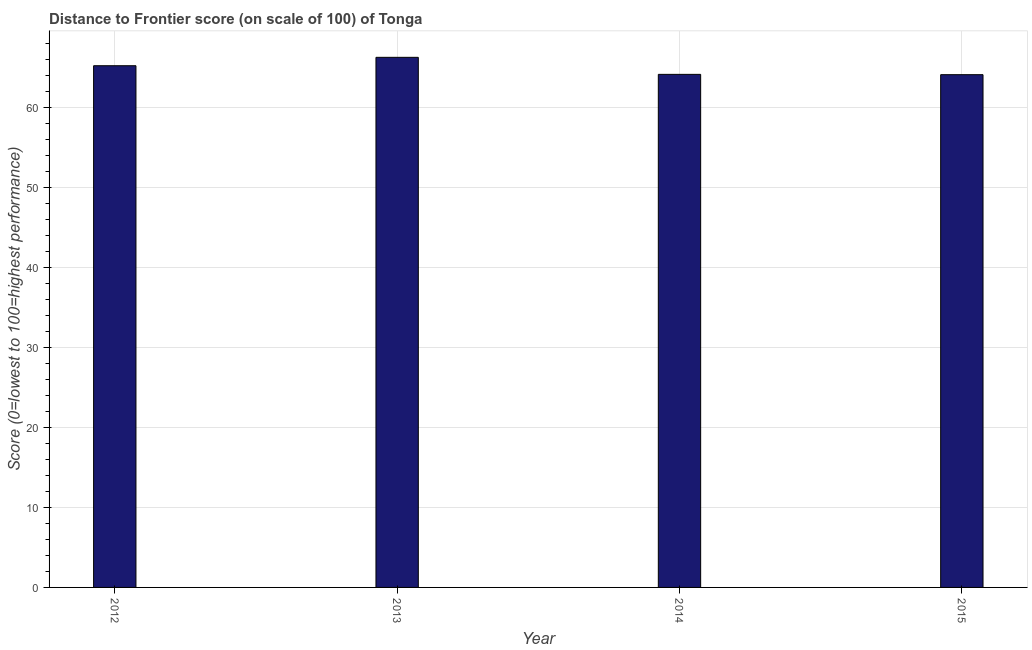Does the graph contain any zero values?
Provide a short and direct response. No. What is the title of the graph?
Offer a terse response. Distance to Frontier score (on scale of 100) of Tonga. What is the label or title of the X-axis?
Offer a very short reply. Year. What is the label or title of the Y-axis?
Give a very brief answer. Score (0=lowest to 100=highest performance). What is the distance to frontier score in 2014?
Provide a short and direct response. 64.17. Across all years, what is the maximum distance to frontier score?
Give a very brief answer. 66.3. Across all years, what is the minimum distance to frontier score?
Make the answer very short. 64.13. In which year was the distance to frontier score minimum?
Give a very brief answer. 2015. What is the sum of the distance to frontier score?
Provide a short and direct response. 259.85. What is the difference between the distance to frontier score in 2013 and 2015?
Your answer should be very brief. 2.17. What is the average distance to frontier score per year?
Offer a very short reply. 64.96. What is the median distance to frontier score?
Ensure brevity in your answer.  64.71. In how many years, is the distance to frontier score greater than 58 ?
Offer a very short reply. 4. Do a majority of the years between 2013 and 2012 (inclusive) have distance to frontier score greater than 24 ?
Offer a terse response. No. What is the ratio of the distance to frontier score in 2013 to that in 2015?
Offer a very short reply. 1.03. Is the difference between the distance to frontier score in 2012 and 2015 greater than the difference between any two years?
Keep it short and to the point. No. What is the difference between the highest and the second highest distance to frontier score?
Offer a terse response. 1.05. What is the difference between the highest and the lowest distance to frontier score?
Your answer should be very brief. 2.17. How many bars are there?
Make the answer very short. 4. How many years are there in the graph?
Provide a short and direct response. 4. What is the Score (0=lowest to 100=highest performance) in 2012?
Ensure brevity in your answer.  65.25. What is the Score (0=lowest to 100=highest performance) of 2013?
Your response must be concise. 66.3. What is the Score (0=lowest to 100=highest performance) in 2014?
Your answer should be very brief. 64.17. What is the Score (0=lowest to 100=highest performance) of 2015?
Keep it short and to the point. 64.13. What is the difference between the Score (0=lowest to 100=highest performance) in 2012 and 2013?
Your response must be concise. -1.05. What is the difference between the Score (0=lowest to 100=highest performance) in 2012 and 2014?
Your answer should be compact. 1.08. What is the difference between the Score (0=lowest to 100=highest performance) in 2012 and 2015?
Provide a succinct answer. 1.12. What is the difference between the Score (0=lowest to 100=highest performance) in 2013 and 2014?
Your response must be concise. 2.13. What is the difference between the Score (0=lowest to 100=highest performance) in 2013 and 2015?
Provide a succinct answer. 2.17. What is the difference between the Score (0=lowest to 100=highest performance) in 2014 and 2015?
Offer a very short reply. 0.04. What is the ratio of the Score (0=lowest to 100=highest performance) in 2012 to that in 2014?
Make the answer very short. 1.02. What is the ratio of the Score (0=lowest to 100=highest performance) in 2012 to that in 2015?
Provide a succinct answer. 1.02. What is the ratio of the Score (0=lowest to 100=highest performance) in 2013 to that in 2014?
Provide a succinct answer. 1.03. What is the ratio of the Score (0=lowest to 100=highest performance) in 2013 to that in 2015?
Your answer should be very brief. 1.03. What is the ratio of the Score (0=lowest to 100=highest performance) in 2014 to that in 2015?
Provide a short and direct response. 1. 